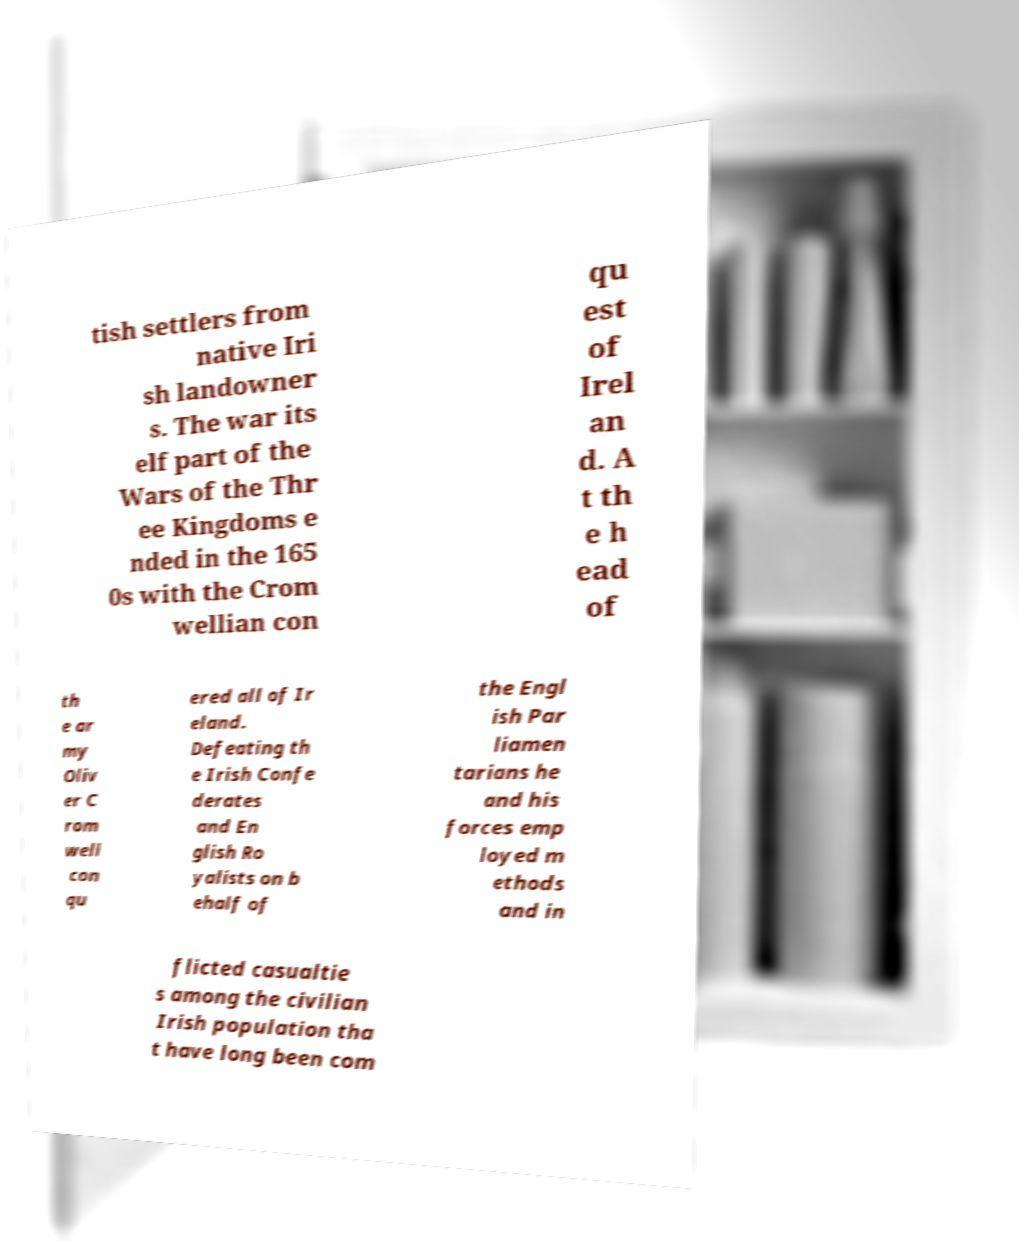Could you extract and type out the text from this image? tish settlers from native Iri sh landowner s. The war its elf part of the Wars of the Thr ee Kingdoms e nded in the 165 0s with the Crom wellian con qu est of Irel an d. A t th e h ead of th e ar my Oliv er C rom well con qu ered all of Ir eland. Defeating th e Irish Confe derates and En glish Ro yalists on b ehalf of the Engl ish Par liamen tarians he and his forces emp loyed m ethods and in flicted casualtie s among the civilian Irish population tha t have long been com 